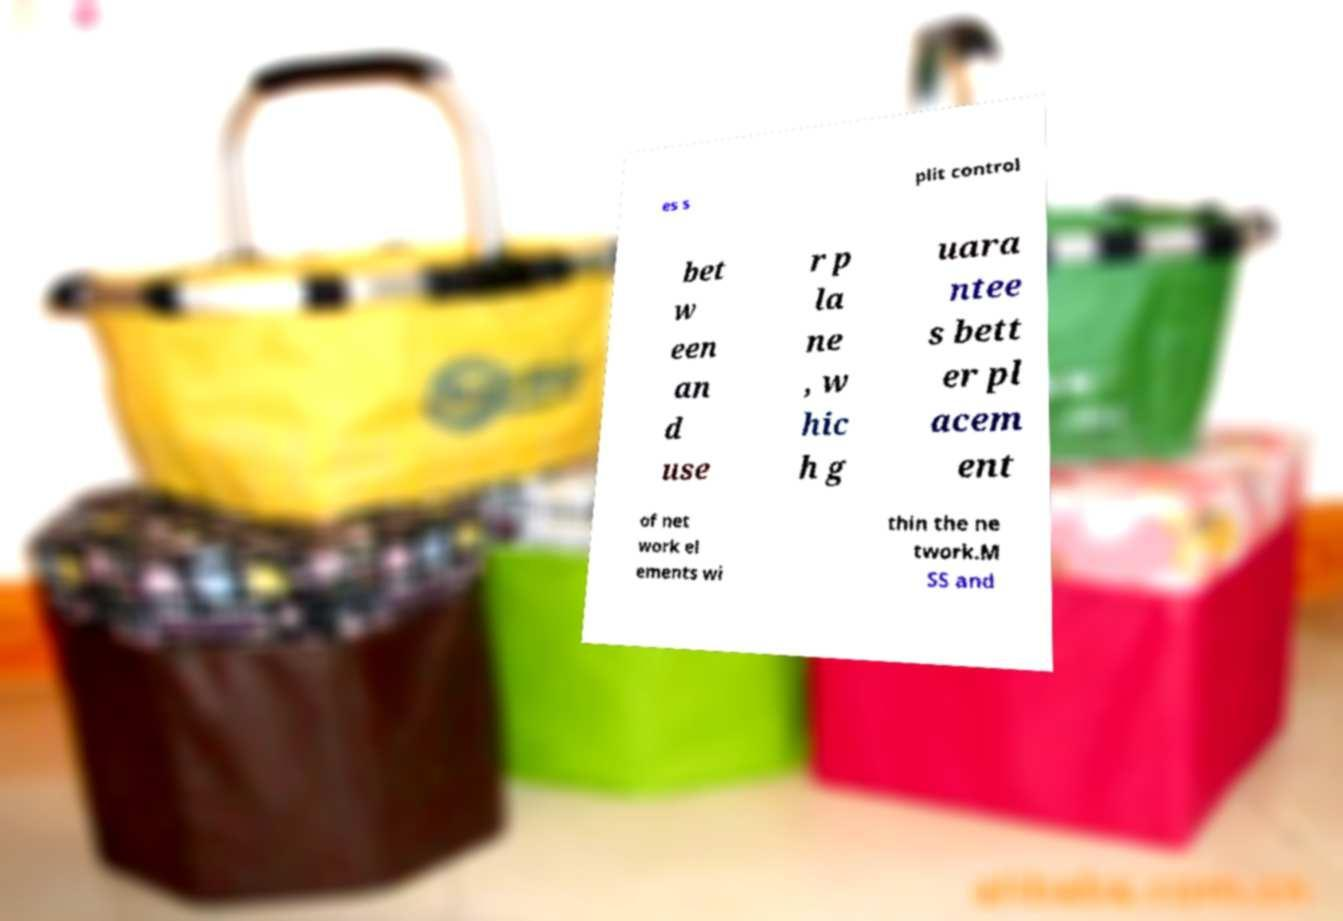Could you assist in decoding the text presented in this image and type it out clearly? es s plit control bet w een an d use r p la ne , w hic h g uara ntee s bett er pl acem ent of net work el ements wi thin the ne twork.M SS and 